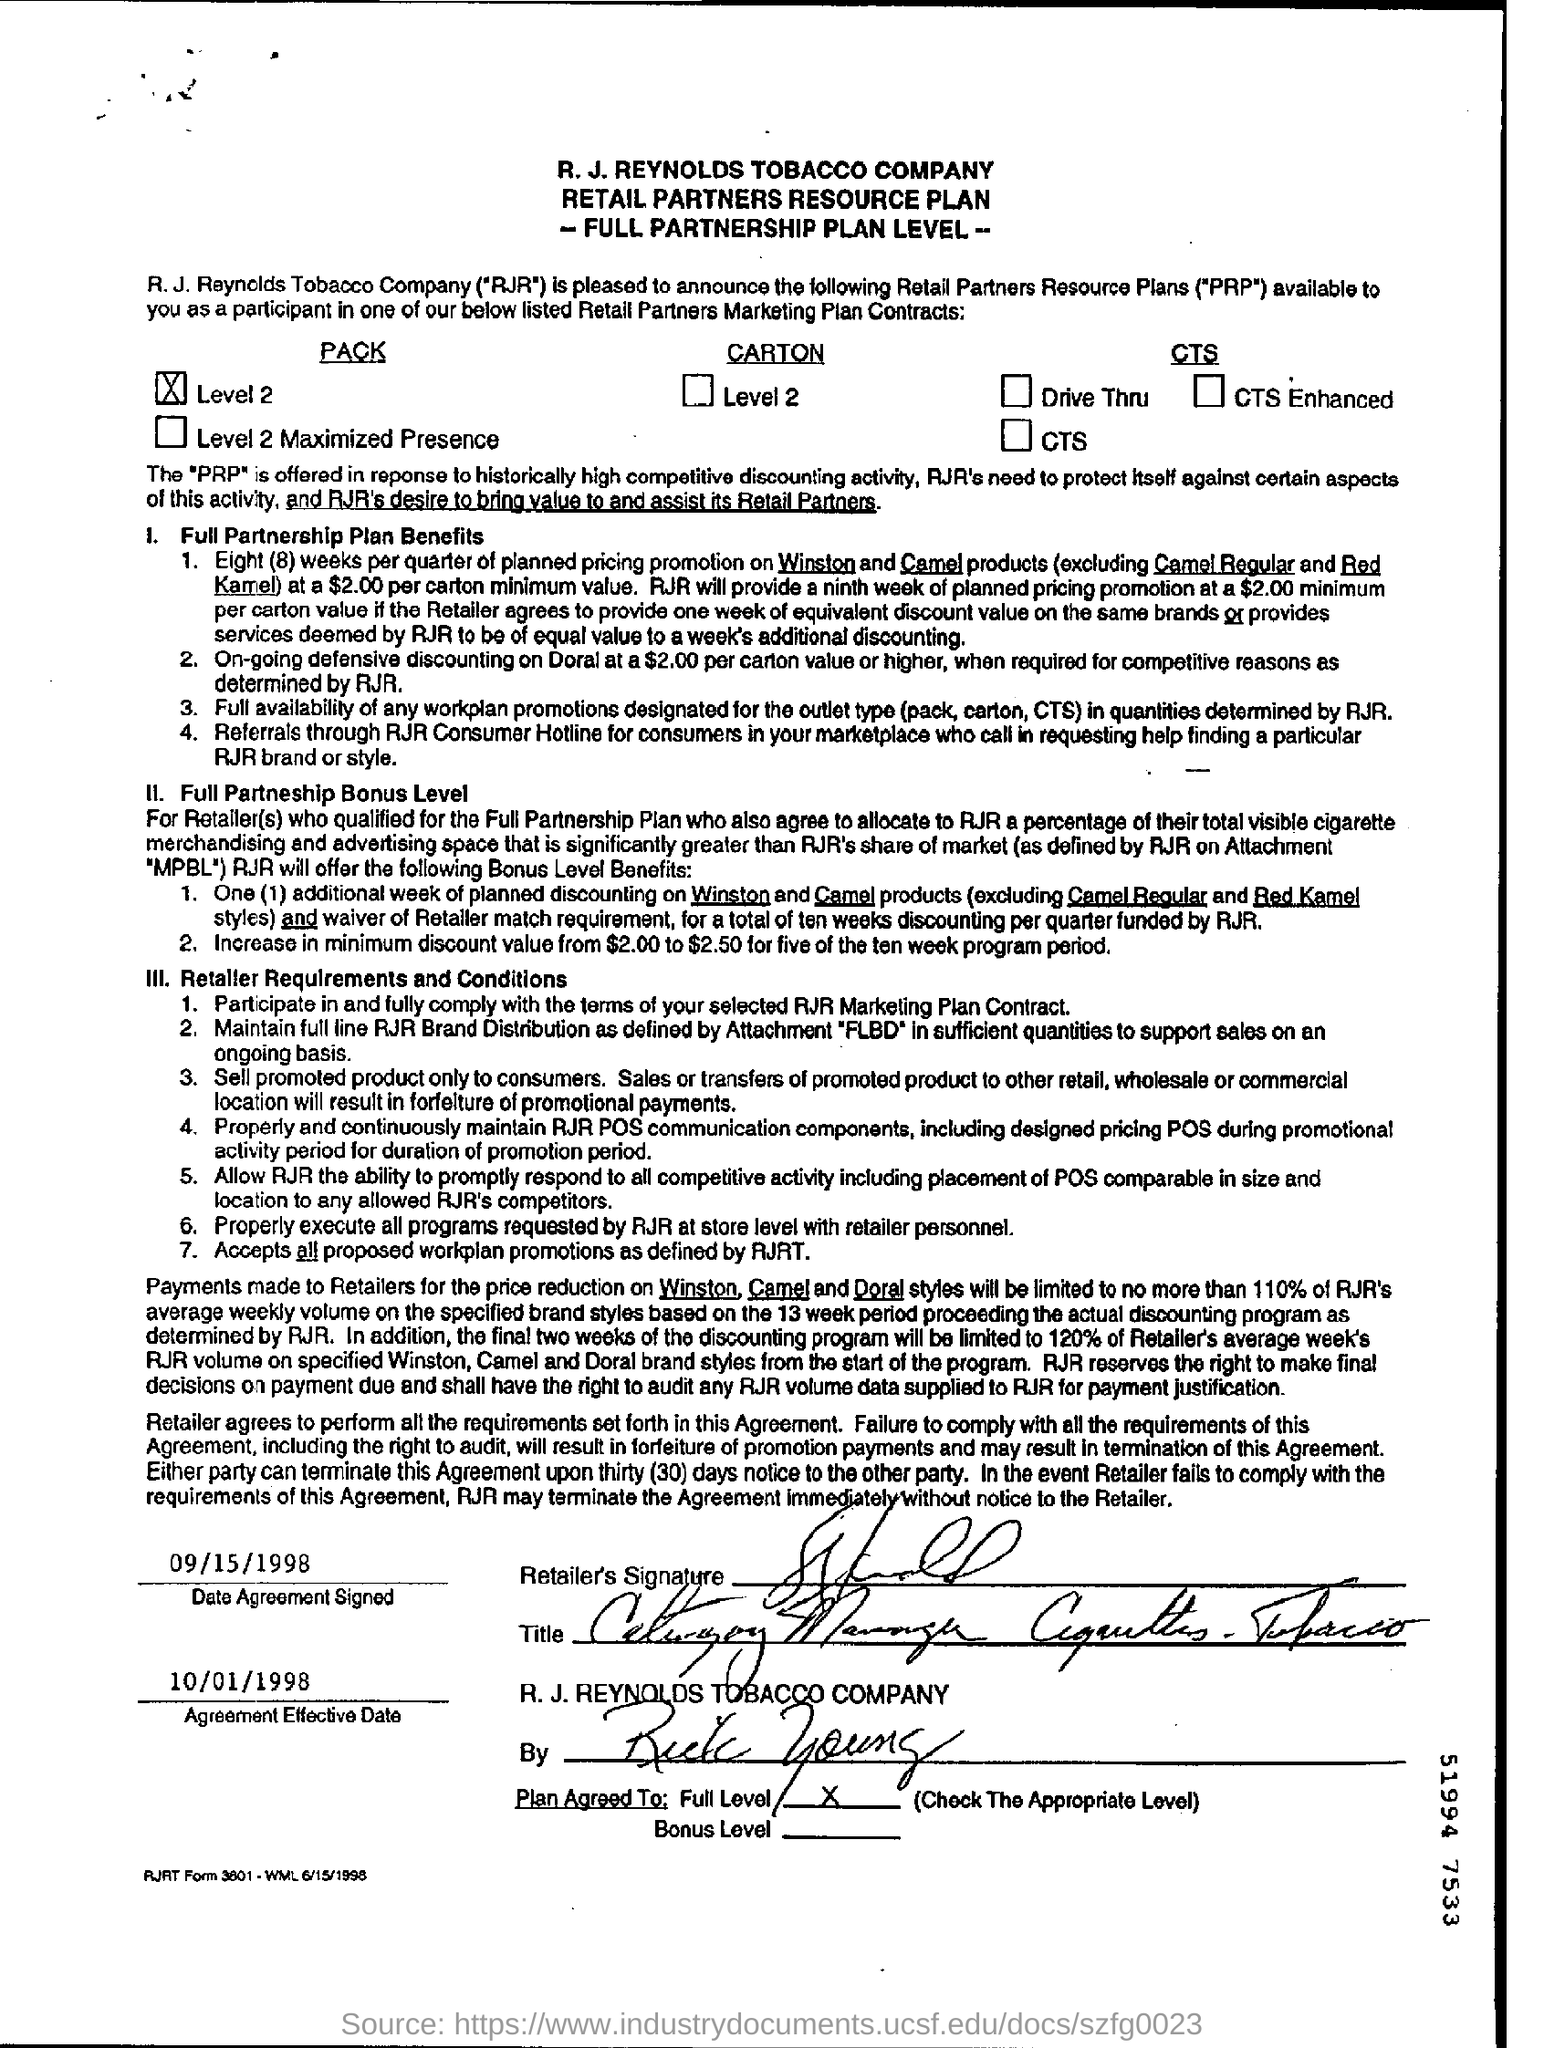Which company's name is at the top of the page?
Keep it short and to the point. R.J. REYNOLDS TOBACCO COMPANY. When was the agreement signed?
Offer a terse response. 09/15/1998. What is the agreement effective date?
Offer a very short reply. 10/01/1998. 